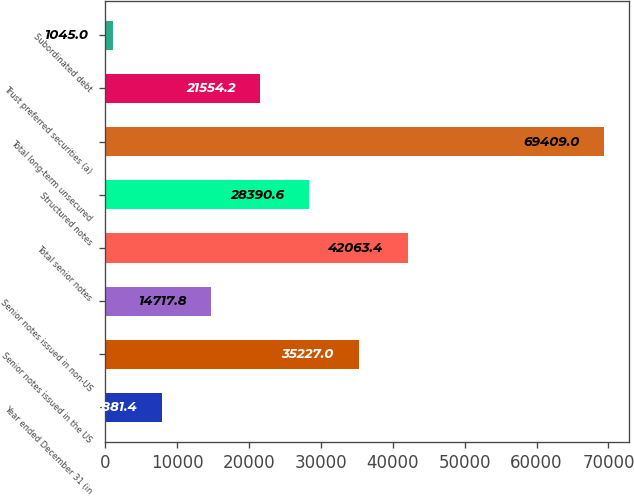Convert chart to OTSL. <chart><loc_0><loc_0><loc_500><loc_500><bar_chart><fcel>Year ended December 31 (in<fcel>Senior notes issued in the US<fcel>Senior notes issued in non-US<fcel>Total senior notes<fcel>Structured notes<fcel>Total long-term unsecured<fcel>Trust preferred securities (a)<fcel>Subordinated debt<nl><fcel>7881.4<fcel>35227<fcel>14717.8<fcel>42063.4<fcel>28390.6<fcel>69409<fcel>21554.2<fcel>1045<nl></chart> 